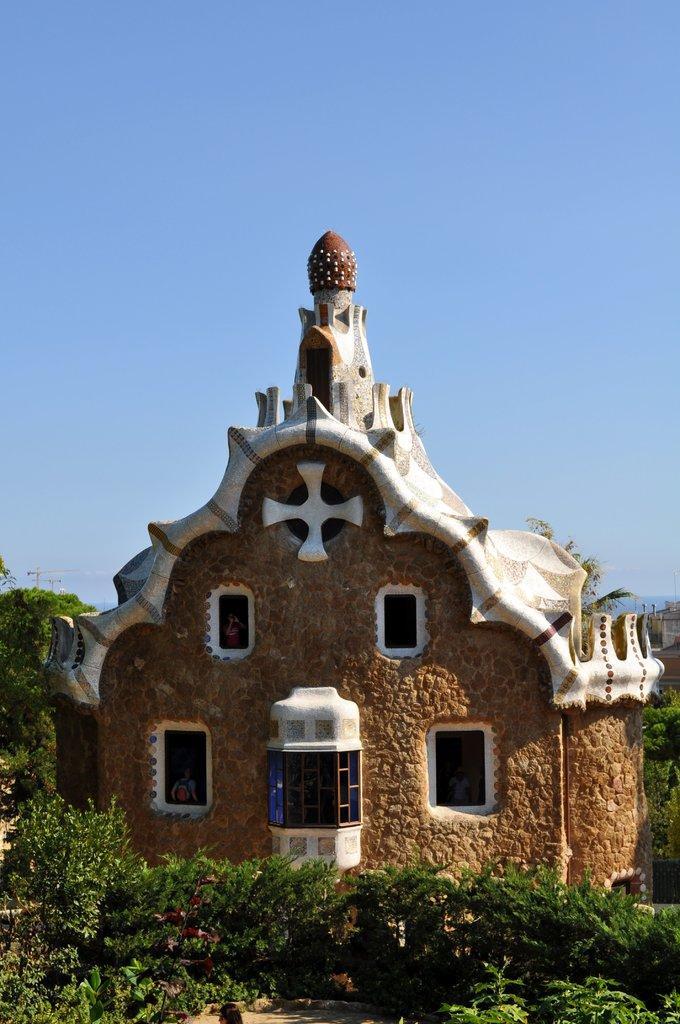Please provide a concise description of this image. In this image I can see number of plants in the front and behind it I can see a building and few trees. I can also see the sky in the background. 